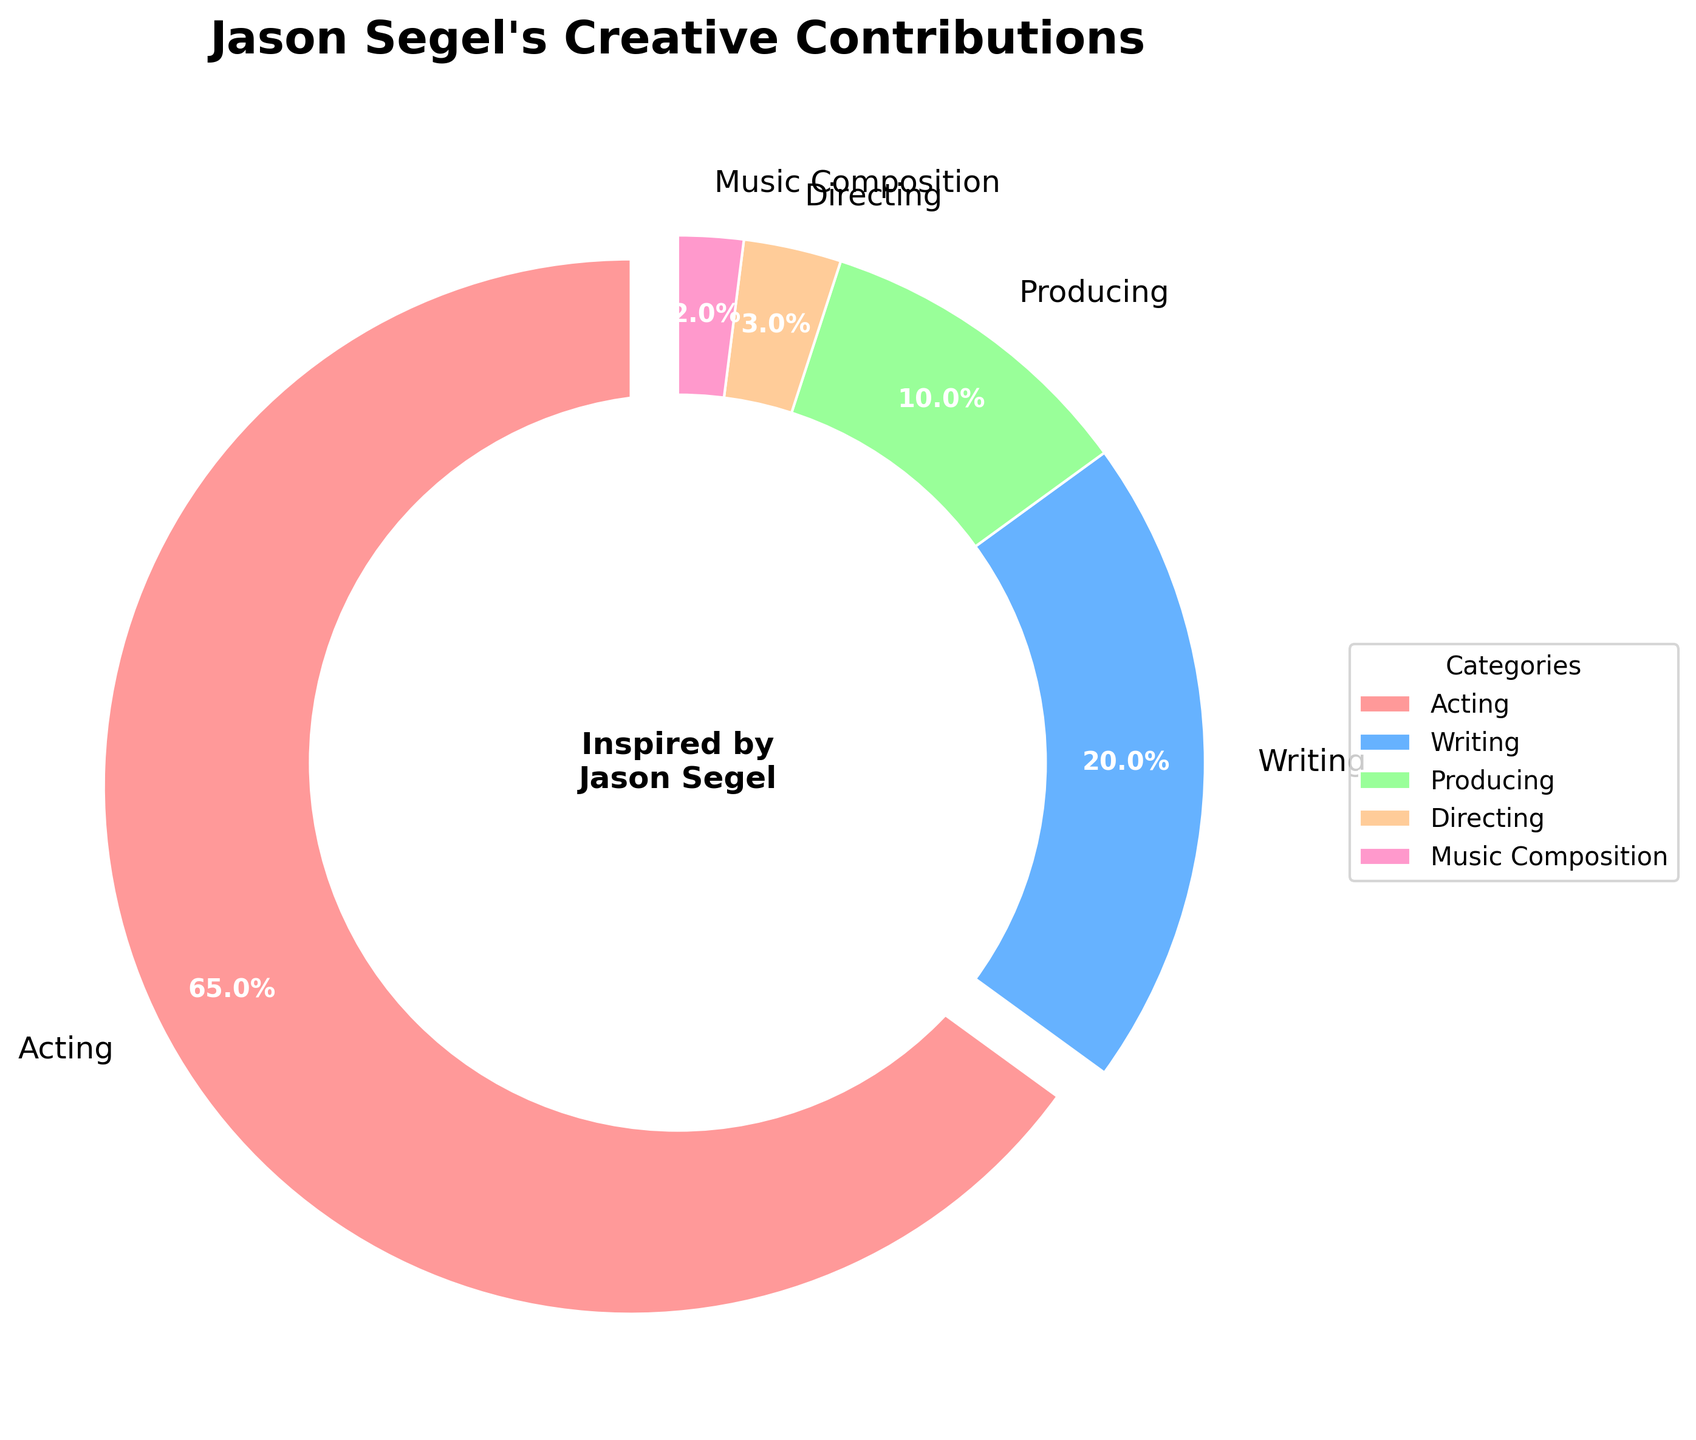What's the most significant contribution Jason Segel has made in his body of work? The largest section of the pie chart, which is indicated by the biggest slice, shows "Acting" with 65%.
Answer: Acting Which contribution is the least among Jason Segel's work? The smallest slice in the pie chart represents "Music Composition" with 2%.
Answer: Music Composition How much more percentage does Jason Segel spend on acting compared to writing? The percentage for acting is 65%, and for writing, it is 20%; thus, 65% - 20% = 45%.
Answer: 45% Combine the contributions of producing and directing. What is their total percentage? Producing accounts for 10% and directing for 3%, so combined: 10% + 3% = 13%.
Answer: 13% Does Jason Segel spend more time on writing or producing? From the pie chart, writing's segment is larger at 20%, while producing is 10%.
Answer: Writing What proportion of his creative efforts are not dedicated to acting? Total contributions are 100%, with acting taking up 65%; thus, the rest is 100% - 65% = 35%.
Answer: 35% Compare acting and all other contributions combined. Which is greater and by how much? Acting is 65% while all other contributions combined are 35%. Acting is greater by 65% - 35% = 30%.
Answer: Acting by 30% What is the combined contribution of directing and music composition, and how does it compare to producing? Directing is 3% and music composition is 2%, combined they are 3% + 2% = 5%. Producing is 10%, so producing is 10% - 5% = 5% more.
Answer: 5% more How does the explosion of the largest wedge of the pie chart affect visual interpretation? The largest wedge, representing acting at 65%, is slightly separated (exploded) from the pie chart, making it visually stand out more. It emphasizes that acting is his primary contribution.
Answer: Emphasis on acting Of writing, producing, and directing, which segment forms the smallest and largest slices, and what are their percentages? Writing is the largest slice at 20%, while directing is the smallest at 3%.
Answer: Writing 20%, Directing 3% 